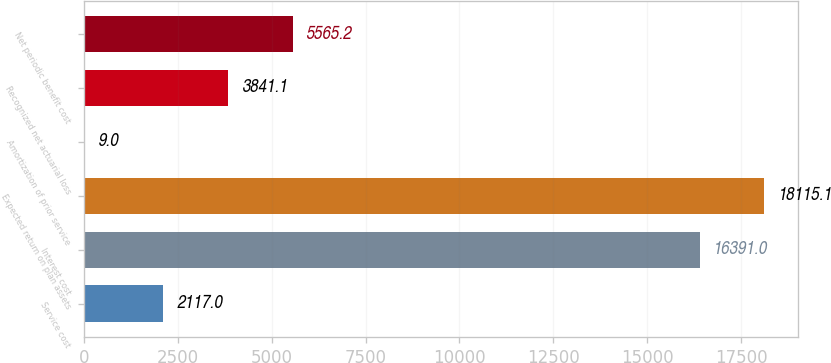<chart> <loc_0><loc_0><loc_500><loc_500><bar_chart><fcel>Service cost<fcel>Interest cost<fcel>Expected return on plan assets<fcel>Amortization of prior service<fcel>Recognized net actuarial loss<fcel>Net periodic benefit cost<nl><fcel>2117<fcel>16391<fcel>18115.1<fcel>9<fcel>3841.1<fcel>5565.2<nl></chart> 